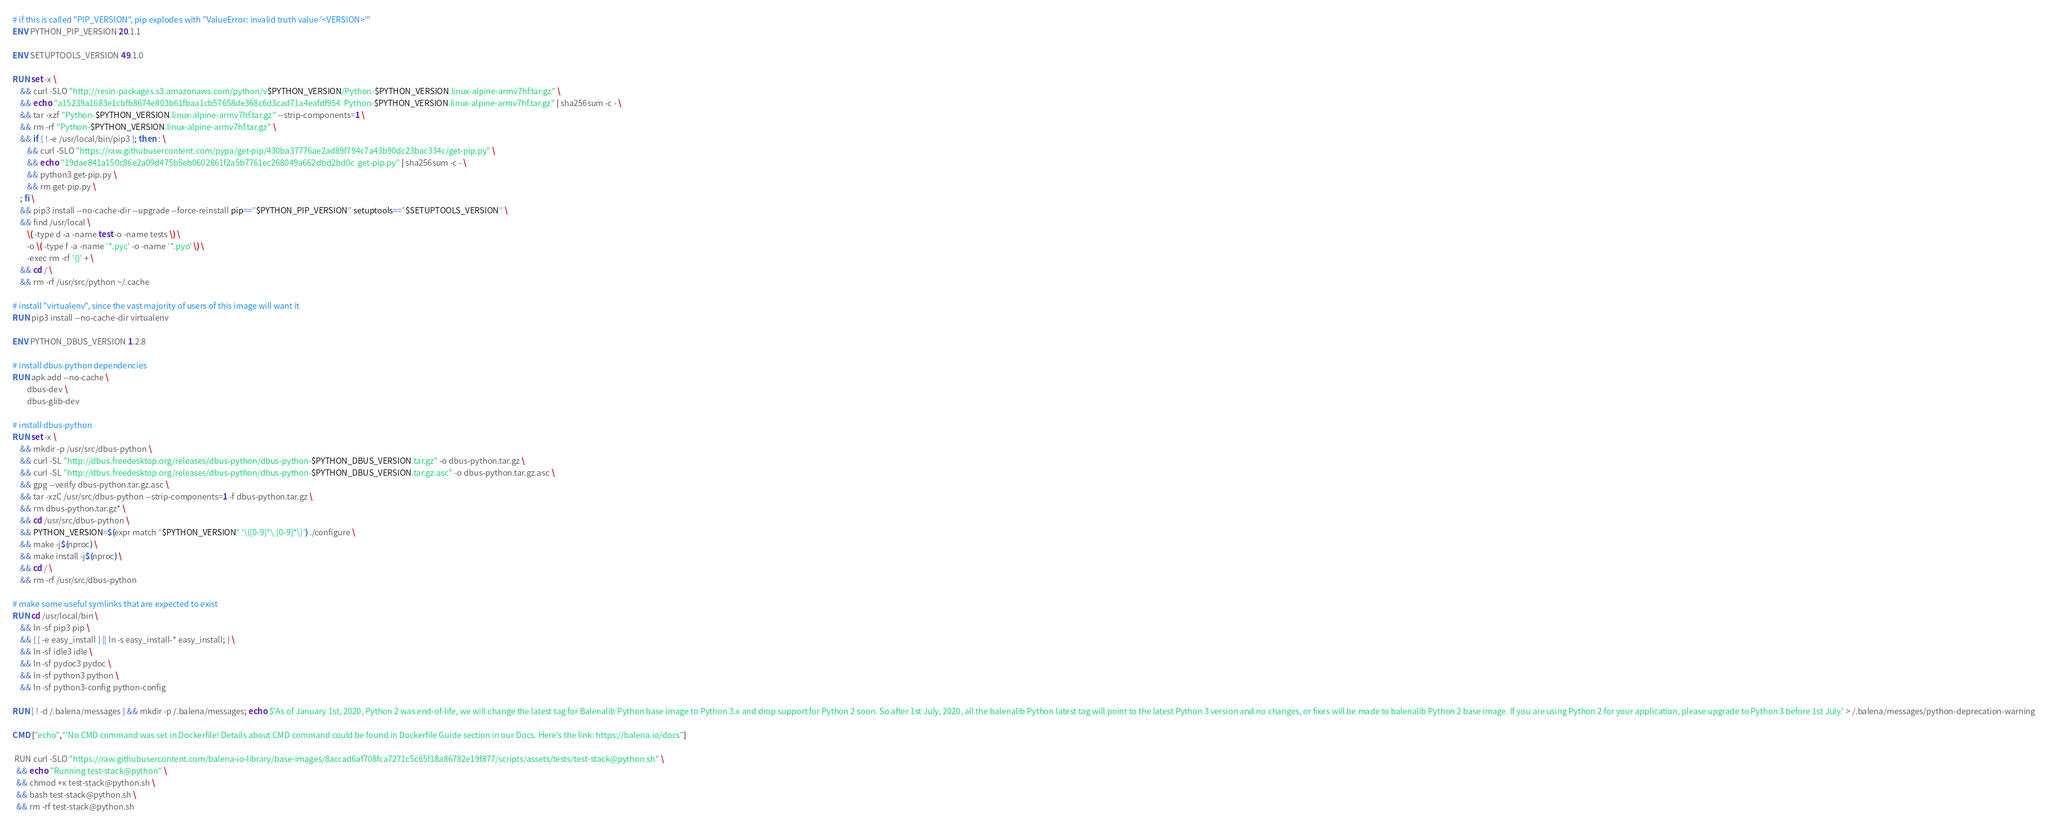Convert code to text. <code><loc_0><loc_0><loc_500><loc_500><_Dockerfile_>
# if this is called "PIP_VERSION", pip explodes with "ValueError: invalid truth value '<VERSION>'"
ENV PYTHON_PIP_VERSION 20.1.1

ENV SETUPTOOLS_VERSION 49.1.0

RUN set -x \
	&& curl -SLO "http://resin-packages.s3.amazonaws.com/python/v$PYTHON_VERSION/Python-$PYTHON_VERSION.linux-alpine-armv7hf.tar.gz" \
	&& echo "a15239a1683e1cbfb8674e803b61fbaa1cb57658de368c6d3cad71a4eafdf954  Python-$PYTHON_VERSION.linux-alpine-armv7hf.tar.gz" | sha256sum -c - \
	&& tar -xzf "Python-$PYTHON_VERSION.linux-alpine-armv7hf.tar.gz" --strip-components=1 \
	&& rm -rf "Python-$PYTHON_VERSION.linux-alpine-armv7hf.tar.gz" \
	&& if [ ! -e /usr/local/bin/pip3 ]; then : \
		&& curl -SLO "https://raw.githubusercontent.com/pypa/get-pip/430ba37776ae2ad89f794c7a43b90dc23bac334c/get-pip.py" \
		&& echo "19dae841a150c86e2a09d475b5eb0602861f2a5b7761ec268049a662dbd2bd0c  get-pip.py" | sha256sum -c - \
		&& python3 get-pip.py \
		&& rm get-pip.py \
	; fi \
	&& pip3 install --no-cache-dir --upgrade --force-reinstall pip=="$PYTHON_PIP_VERSION" setuptools=="$SETUPTOOLS_VERSION" \
	&& find /usr/local \
		\( -type d -a -name test -o -name tests \) \
		-o \( -type f -a -name '*.pyc' -o -name '*.pyo' \) \
		-exec rm -rf '{}' + \
	&& cd / \
	&& rm -rf /usr/src/python ~/.cache

# install "virtualenv", since the vast majority of users of this image will want it
RUN pip3 install --no-cache-dir virtualenv

ENV PYTHON_DBUS_VERSION 1.2.8

# install dbus-python dependencies 
RUN apk add --no-cache \
		dbus-dev \
		dbus-glib-dev

# install dbus-python
RUN set -x \
	&& mkdir -p /usr/src/dbus-python \
	&& curl -SL "http://dbus.freedesktop.org/releases/dbus-python/dbus-python-$PYTHON_DBUS_VERSION.tar.gz" -o dbus-python.tar.gz \
	&& curl -SL "http://dbus.freedesktop.org/releases/dbus-python/dbus-python-$PYTHON_DBUS_VERSION.tar.gz.asc" -o dbus-python.tar.gz.asc \
	&& gpg --verify dbus-python.tar.gz.asc \
	&& tar -xzC /usr/src/dbus-python --strip-components=1 -f dbus-python.tar.gz \
	&& rm dbus-python.tar.gz* \
	&& cd /usr/src/dbus-python \
	&& PYTHON_VERSION=$(expr match "$PYTHON_VERSION" '\([0-9]*\.[0-9]*\)') ./configure \
	&& make -j$(nproc) \
	&& make install -j$(nproc) \
	&& cd / \
	&& rm -rf /usr/src/dbus-python

# make some useful symlinks that are expected to exist
RUN cd /usr/local/bin \
	&& ln -sf pip3 pip \
	&& { [ -e easy_install ] || ln -s easy_install-* easy_install; } \
	&& ln -sf idle3 idle \
	&& ln -sf pydoc3 pydoc \
	&& ln -sf python3 python \
	&& ln -sf python3-config python-config

RUN [ ! -d /.balena/messages ] && mkdir -p /.balena/messages; echo $'As of January 1st, 2020, Python 2 was end-of-life, we will change the latest tag for Balenalib Python base image to Python 3.x and drop support for Python 2 soon. So after 1st July, 2020, all the balenalib Python latest tag will point to the latest Python 3 version and no changes, or fixes will be made to balenalib Python 2 base image. If you are using Python 2 for your application, please upgrade to Python 3 before 1st July.' > /.balena/messages/python-deprecation-warning

CMD ["echo","'No CMD command was set in Dockerfile! Details about CMD command could be found in Dockerfile Guide section in our Docs. Here's the link: https://balena.io/docs"]

 RUN curl -SLO "https://raw.githubusercontent.com/balena-io-library/base-images/8accad6af708fca7271c5c65f18a86782e19f877/scripts/assets/tests/test-stack@python.sh" \
  && echo "Running test-stack@python" \
  && chmod +x test-stack@python.sh \
  && bash test-stack@python.sh \
  && rm -rf test-stack@python.sh 
</code> 